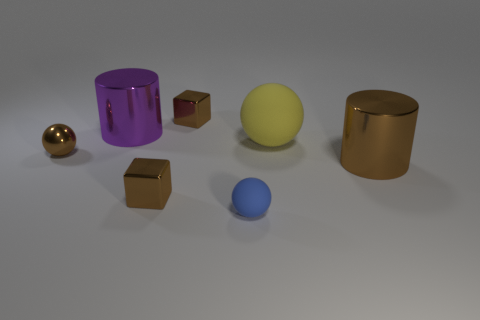Subtract all brown metal spheres. How many spheres are left? 2 Add 3 brown cylinders. How many objects exist? 10 Subtract 0 yellow cylinders. How many objects are left? 7 Subtract all blocks. How many objects are left? 5 Subtract all big balls. Subtract all big brown cylinders. How many objects are left? 5 Add 5 cubes. How many cubes are left? 7 Add 6 large brown cylinders. How many large brown cylinders exist? 7 